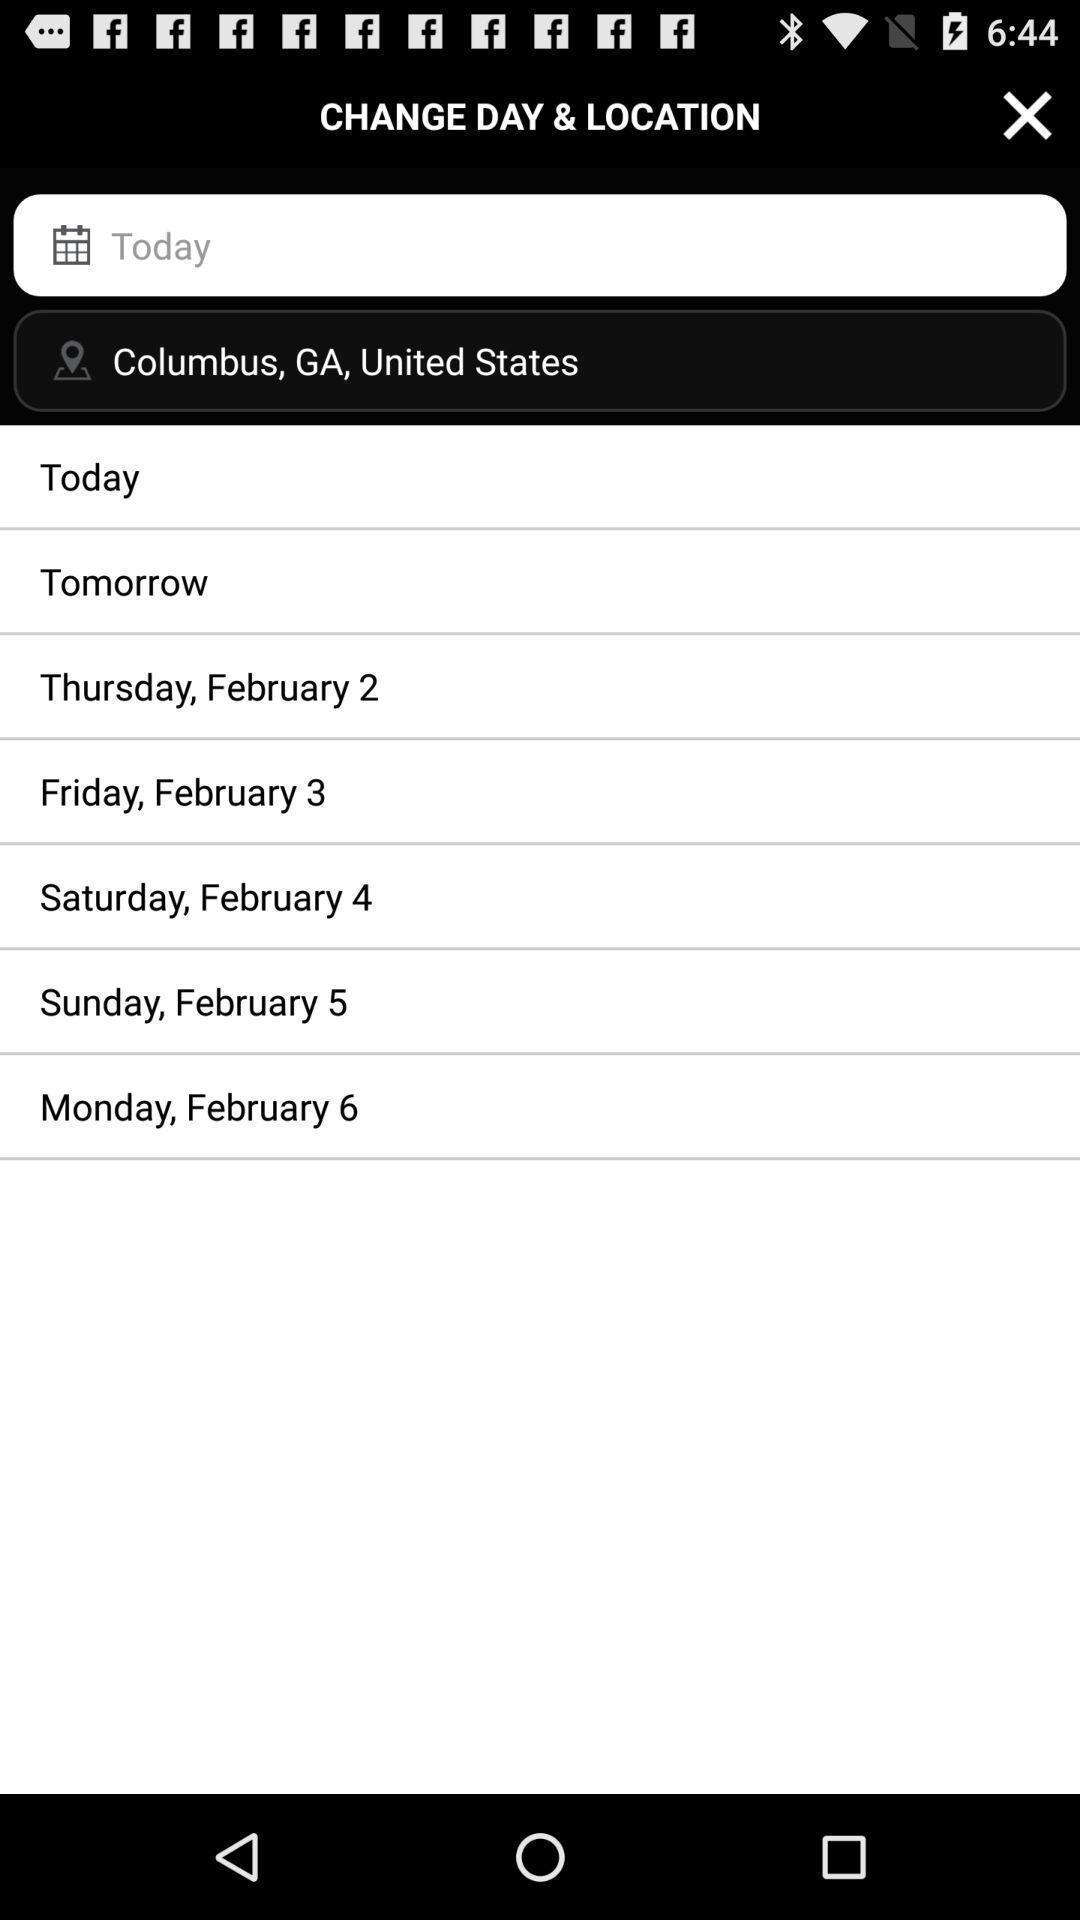Describe the key features of this screenshot. Search for calendar dates in a booking app. 